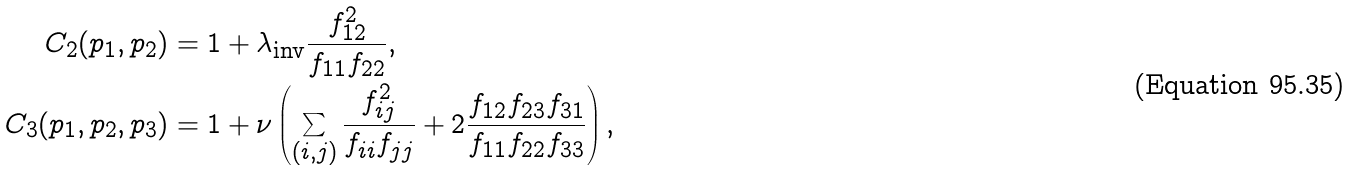Convert formula to latex. <formula><loc_0><loc_0><loc_500><loc_500>C _ { 2 } ( p _ { 1 } , p _ { 2 } ) & = 1 + \lambda _ { \text {inv} } \frac { f _ { 1 2 } ^ { 2 } } { f _ { 1 1 } f _ { 2 2 } } , \\ C _ { 3 } ( p _ { 1 } , p _ { 2 } , p _ { 3 } ) & = 1 + \nu \left ( \sum _ { ( i , j ) } \frac { f _ { i j } ^ { 2 } } { f _ { i i } f _ { j j } } + 2 \frac { f _ { 1 2 } f _ { 2 3 } f _ { 3 1 } } { f _ { 1 1 } f _ { 2 2 } f _ { 3 3 } } \right ) ,</formula> 